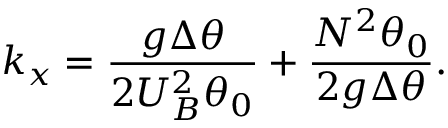Convert formula to latex. <formula><loc_0><loc_0><loc_500><loc_500>k _ { x } = \frac { g \Delta \theta } { 2 { U } _ { B } ^ { 2 } \theta _ { 0 } } + \frac { N ^ { 2 } \theta _ { 0 } } { 2 g \Delta \theta } .</formula> 